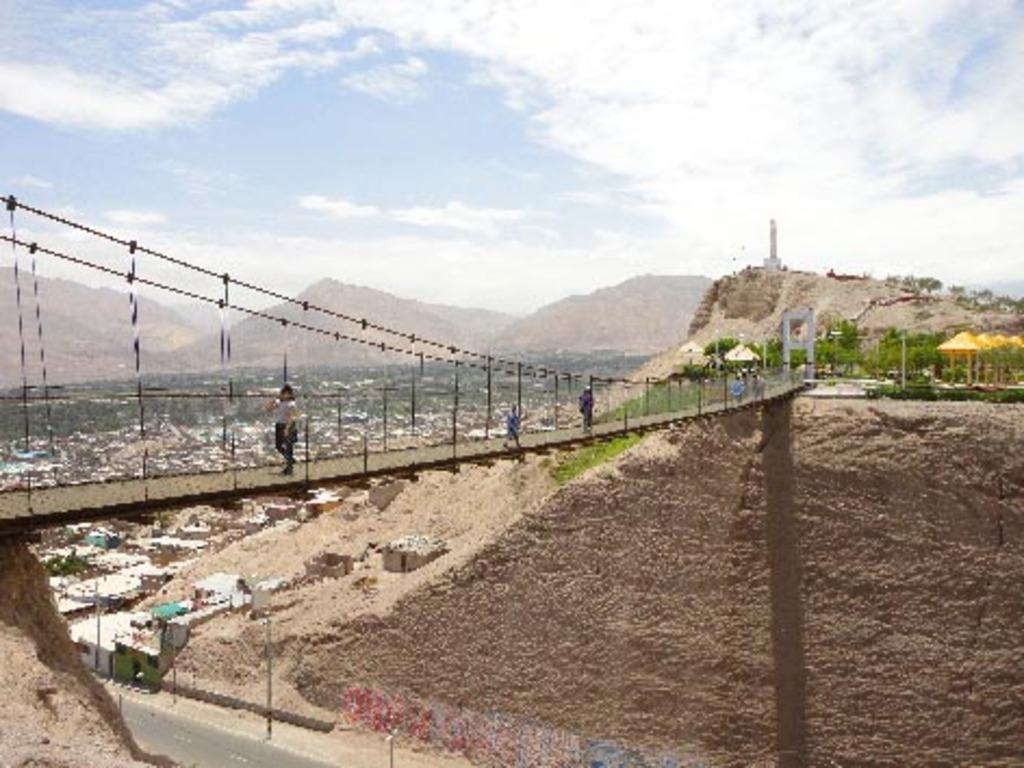How would you summarize this image in a sentence or two? In the foreground, I can see a group of people on the bridge and light poles. In the background, I can see trees, houses, buildings, mountains, towers and the sky. This picture might be taken in a day. 